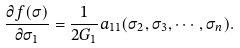<formula> <loc_0><loc_0><loc_500><loc_500>\frac { \partial f ( \sigma ) } { \partial \sigma _ { 1 } } = \frac { 1 } { 2 G _ { 1 } } a _ { 1 1 } ( \sigma _ { 2 } , \sigma _ { 3 } , \cdots , \sigma _ { n } ) .</formula> 